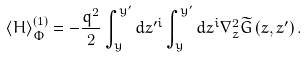Convert formula to latex. <formula><loc_0><loc_0><loc_500><loc_500>\left \langle H \right \rangle _ { \Phi } ^ { \left ( 1 \right ) } = - \frac { q ^ { 2 } } { 2 } \int _ { y } ^ { { y } ^ { \prime } } { d z ^ { \prime i } } \int _ { y } ^ { { y } ^ { \prime } } { d z ^ { i } } \nabla _ { z } ^ { 2 } \widetilde { G } \left ( { { z } , { z } ^ { \prime } } \right ) .</formula> 